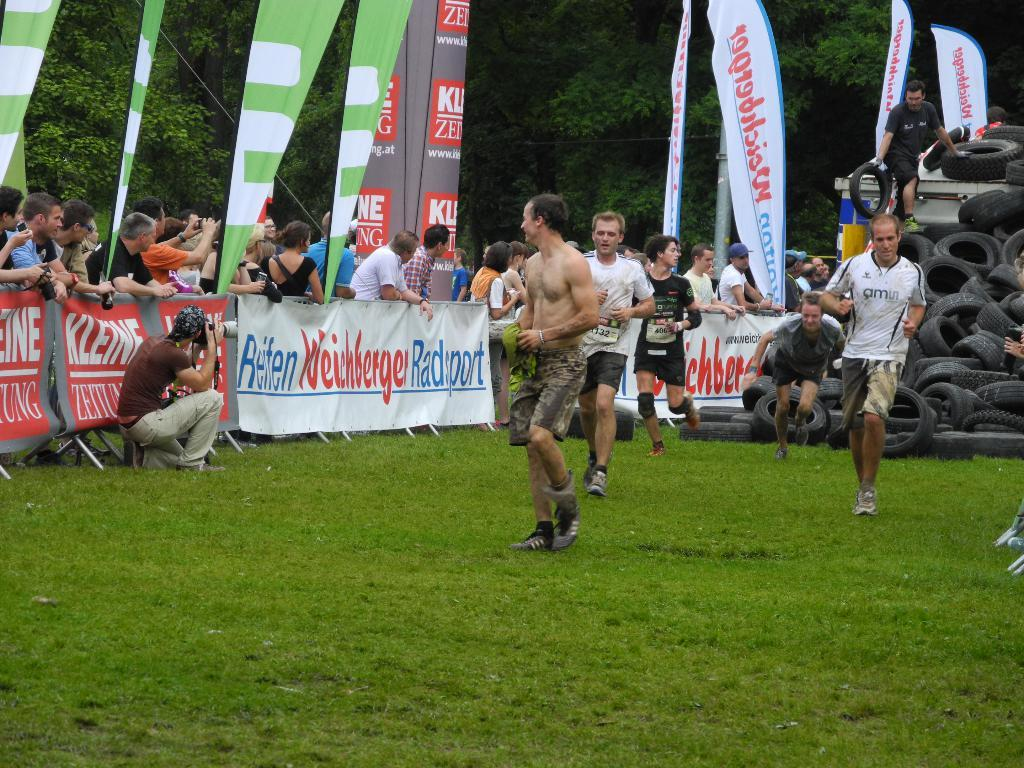<image>
Summarize the visual content of the image. men running in front of a banner that says 'reifen weichberger radsport' 